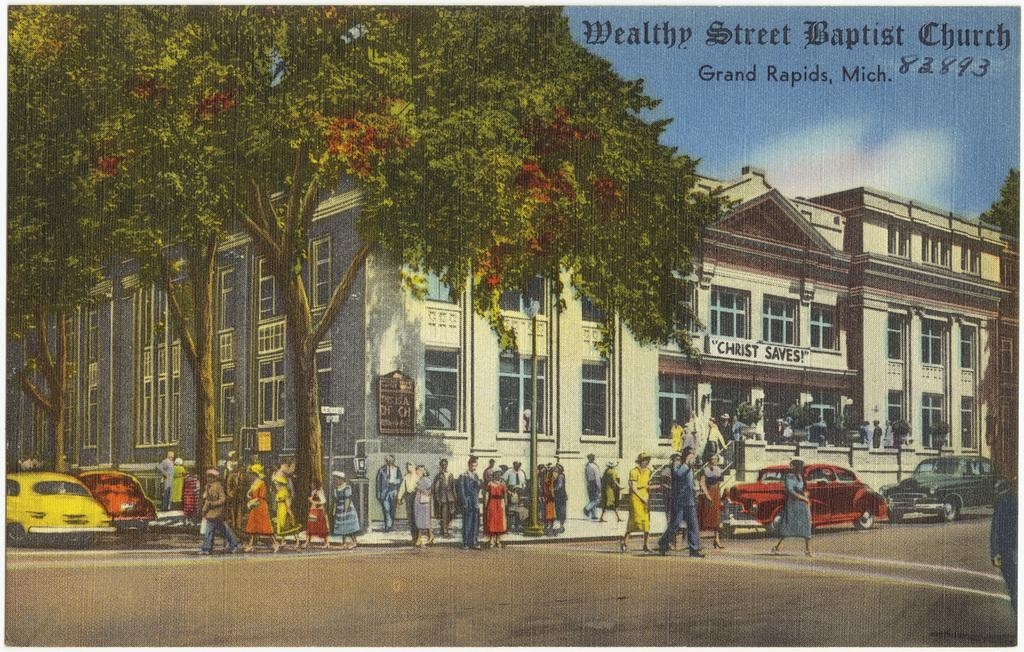What can be seen hanging on the wall in the image? There is a poster visible on the wall in the image. Who or what can be seen in the image? There are people visible in the image. What is happening on the road in the image? Vehicles are present on the road in the image. What can be seen in the distance in the image? There is a building and trees visible in the background of the image. What is written on the building in the background? There is some text present on the building in the background. What type of cable can be seen connecting the people in the image? There is no cable connecting the people in the image; they are not physically connected. What class is being taught in the image? There is no class being taught in the image; it does not depict a learning environment. 